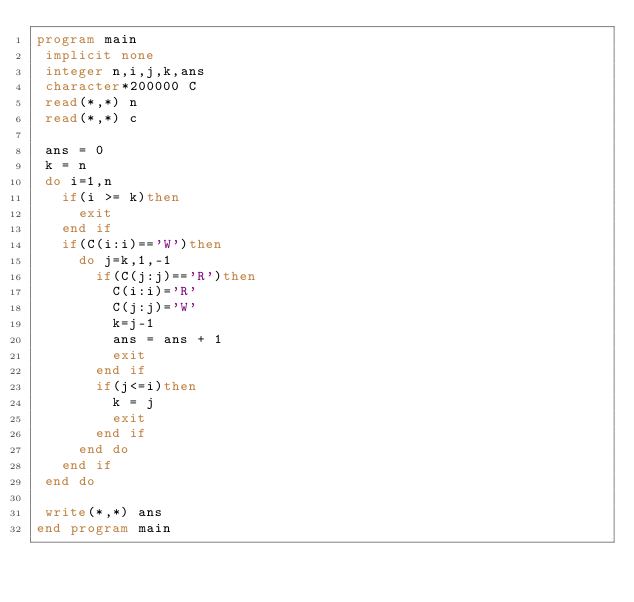<code> <loc_0><loc_0><loc_500><loc_500><_FORTRAN_>program main
 implicit none
 integer n,i,j,k,ans
 character*200000 C
 read(*,*) n
 read(*,*) c
 
 ans = 0
 k = n
 do i=1,n
   if(i >= k)then
     exit
   end if
   if(C(i:i)=='W')then
     do j=k,1,-1
       if(C(j:j)=='R')then
         C(i:i)='R'
         C(j:j)='W'
         k=j-1
         ans = ans + 1
         exit
       end if
       if(j<=i)then
         k = j
         exit
       end if
     end do
   end if
 end do
 
 write(*,*) ans
end program main</code> 